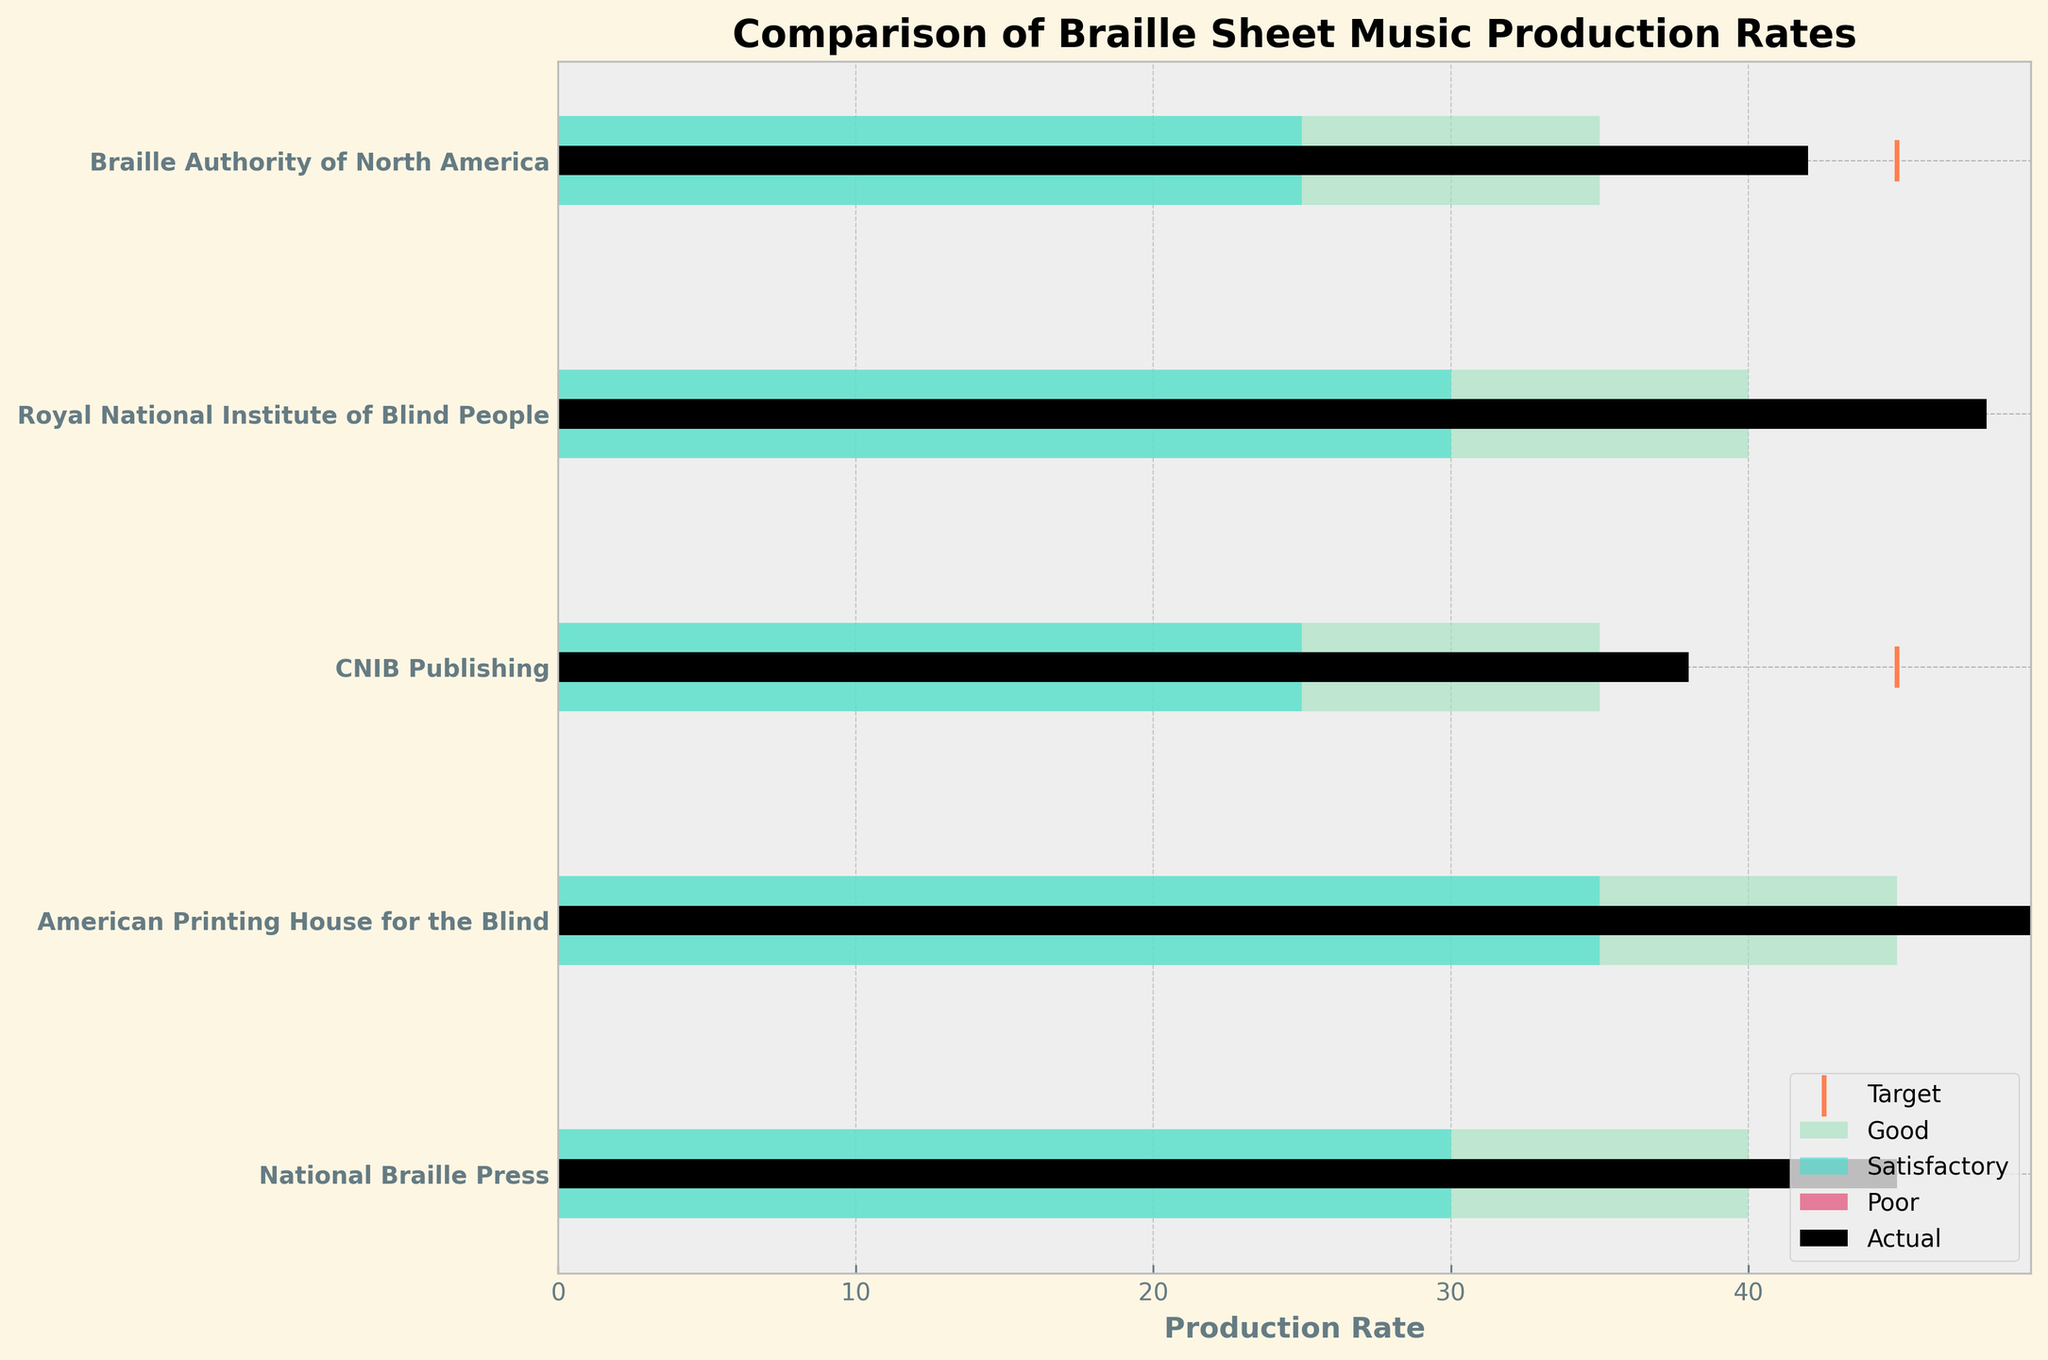What is the title of the figure? The title of the figure is typically found at the top in larger font sizes and reading "Comparison of Braille Sheet Music Production Rates".
Answer: Comparison of Braille Sheet Music Production Rates Which publisher has the highest actual production rate? Look at the black bars which represent actual production rates and find the tallest one; it corresponds to "American Printing House for the Blind" with a rate of 52.
Answer: American Printing House for the Blind How many publishers are compared in the figure? Count the number of different horizontal bars; there are five publishers listed on the y-axis.
Answer: Five Is there any publisher whose actual production rate exactly meets the target production rate? Compare the length of the black bars (actual) with the orange line markers (target). No black bar matches its corresponding orange marker exactly.
Answer: No Which publisher has the smallest target production rate? Look at the orange line markers and find the one with the lowest value. For "CNIB Publishing," this value is 45.
Answer: CNIB Publishing Which publisher has a good production rate range that starts at the lowest value? Compare the start of the green bars which represent the "Good" range. "CNIB Publishing" starts at 35, which is lower than other publishers.
Answer: CNIB Publishing What is the satisfactory range for the "Royal National Institute of Blind People"? Find the light turquoise bars associated with the "Royal National Institute of Blind People" and note the range values given as 30 to 40.
Answer: 30 to 40 Compare the actual production rates of "National Braille Press" and "Braille Authority of North America". Look at the black bars; "National Braille Press" has an actual rate of 45 while "Braille Authority of North America" has a rate of 42 which means "National Braille Press" has a higher actual production rate by 3.
Answer: National Braille Press has a higher rate by 3 Does the "American Printing House for the Blind" meet its target production rate? Compare the length of the black bar for "American Printing House for the Blind" (52) with its orange target line (55). The actual rate is less than the target.
Answer: No Which publisher has an actual production rate greater than the upper bound of the good production rate for any other publisher? Compare all black bars with the end value of any green bar. "American Printing House for the Blind" (actual 52) surpasses the top good range value of all publishers, which is 45.
Answer: American Printing House for the Blind 